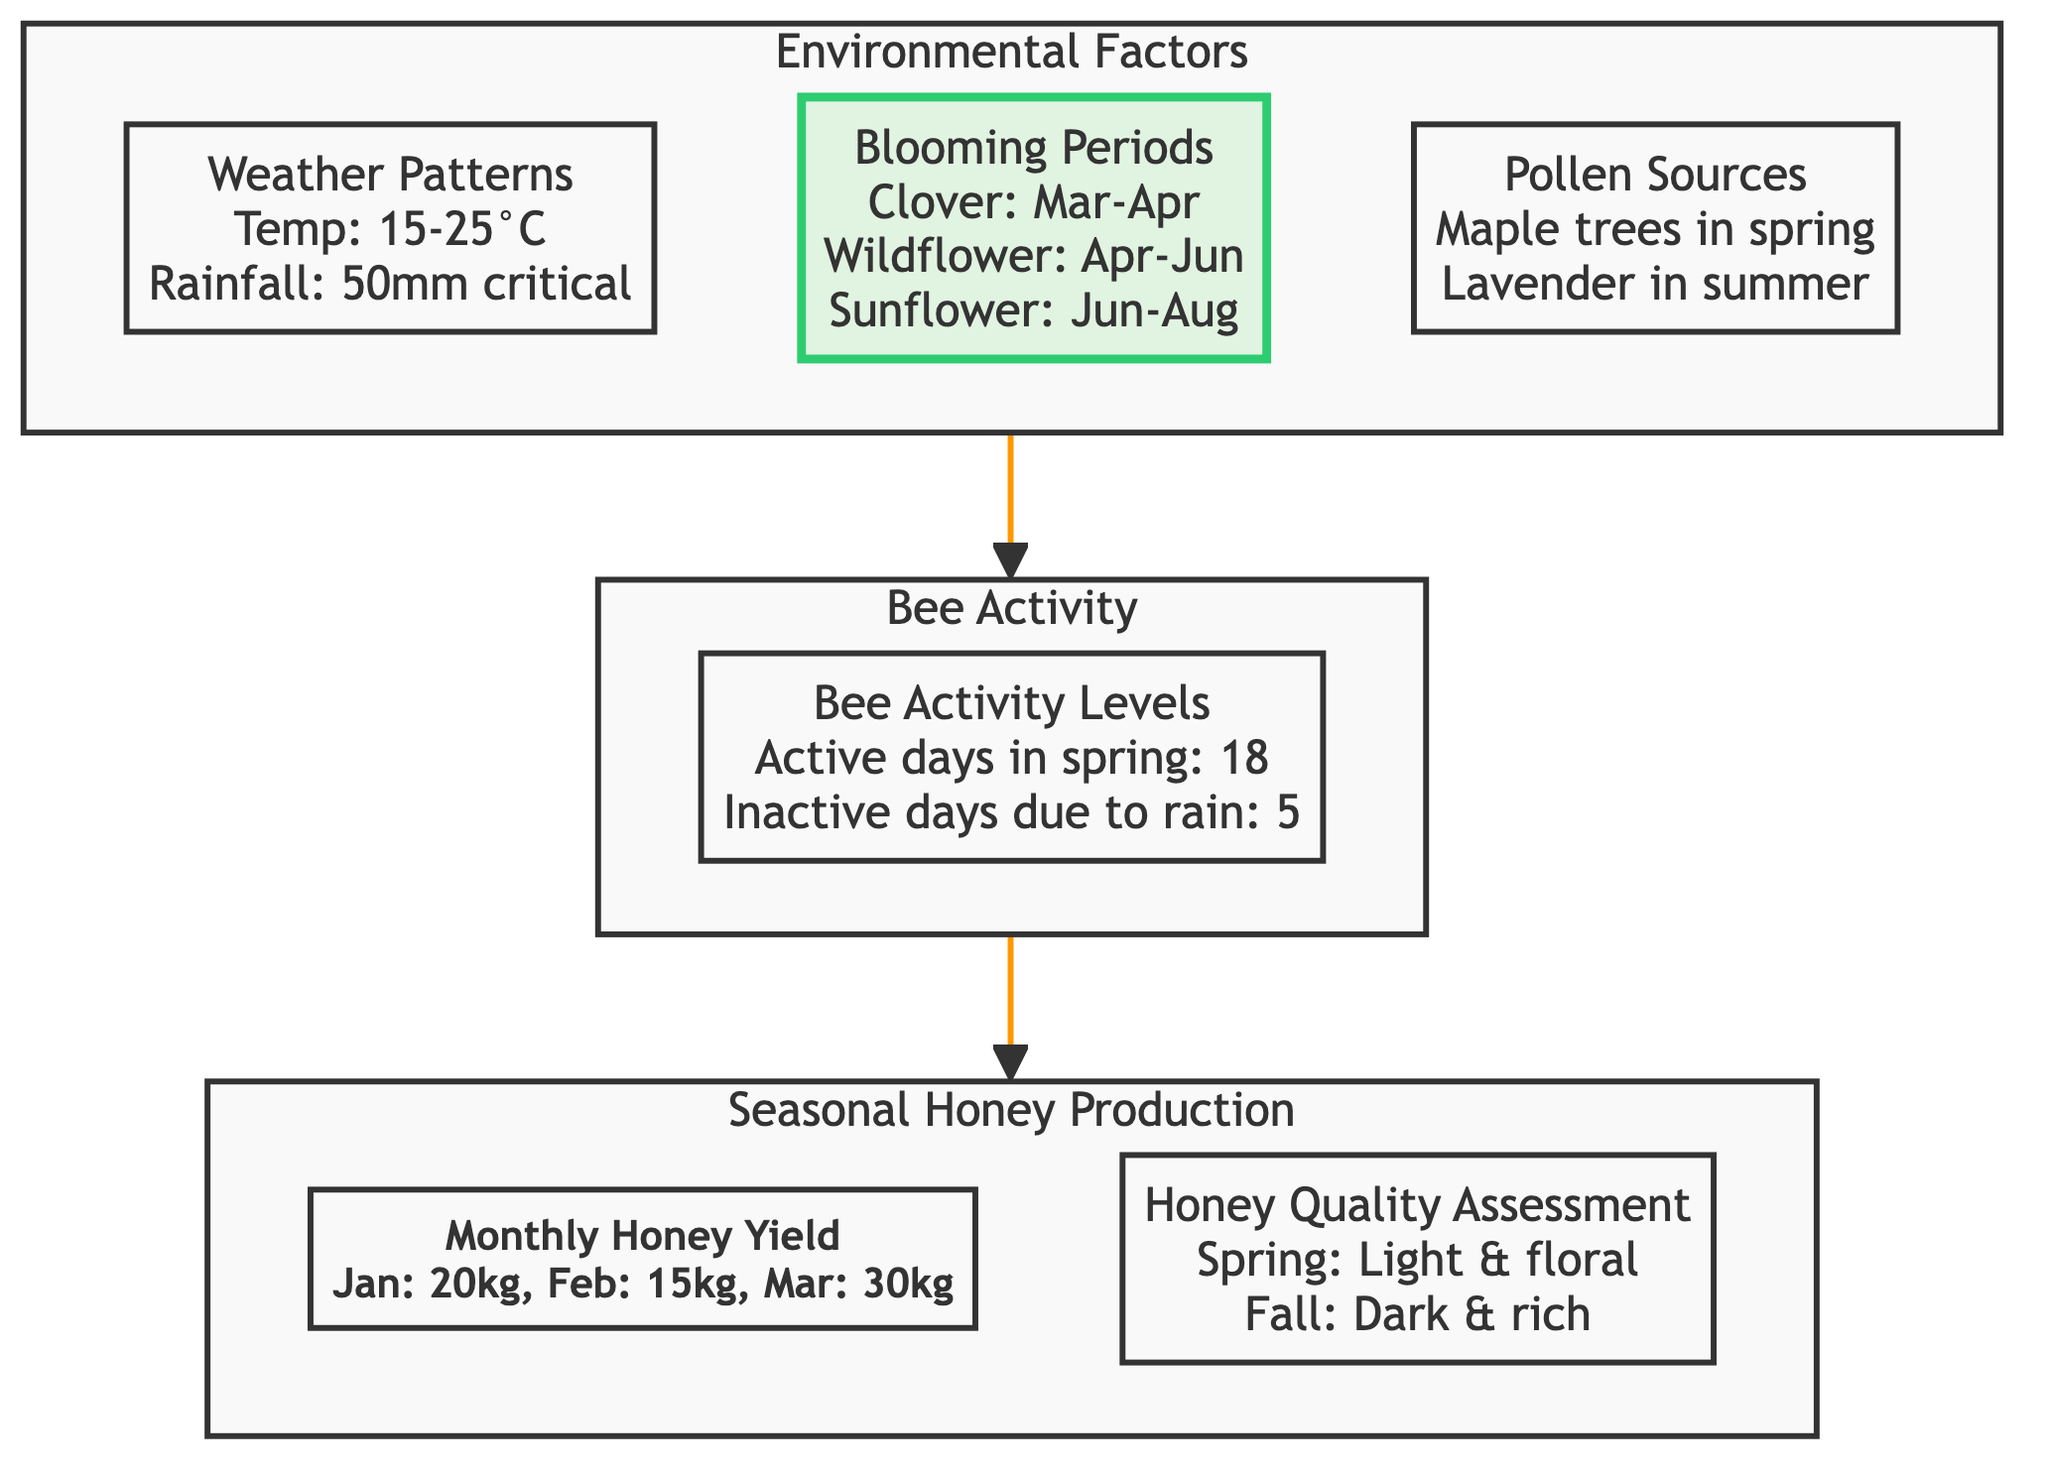What are the blooming periods for flowering plants? The diagram identifies the blooming periods for flowering plants in the area, such as Clover from March to April, Wildflower from April to June, and Sunflower from June to August.
Answer: Clover: March - April, Wildflower: April - June, Sunflower: June - August How much honey is produced in March? According to the diagram, the monthly honey yield for March is specified as 30 kg.
Answer: 30 kg What is the preferred temperature range for bee activity? The diagram indicates that the weather patterns show a preferred temperature range of 15 to 25 degrees Celsius for optimal bee activity.
Answer: 15-25°C How does bee activity relate to environmental factors in the diagram? The diagram shows that environmental factors such as weather patterns and blooming periods influence bee activity levels, demonstrating a flow from the environmental factors to bee activity.
Answer: Environmental factors influence bee activity What is the total number of nodes in the diagram? The diagram contains a total of 6 nodes: Monthly Honey Yield, Honey Quality Assessment, Weather Patterns, Blooming Periods, Pollen Sources, and Bee Activity Levels.
Answer: 6 Which type of honey is described as dark and rich? The diagram classifies fall honey as dark and rich in the honey quality assessment section.
Answer: Fall honey How do bee activity levels affect honey production? The diagram illustrates a direct relationship where bee activity levels impact honey production by showing how increased activity leads to higher monthly honey yields.
Answer: Increased bee activity affects honey production positively What defines the quality of spring honey? The diagram states that spring honey is characterized as light and floral in the honey quality assessment node.
Answer: Light and floral What links the environmental factors to the seasonal honey production? The flowchart indicates that environmental factors, such as weather patterns and blooming periods, lead to increased bee activity, which in turn influences seasonal honey production.
Answer: Environmental factors link to honey production through bee activity 